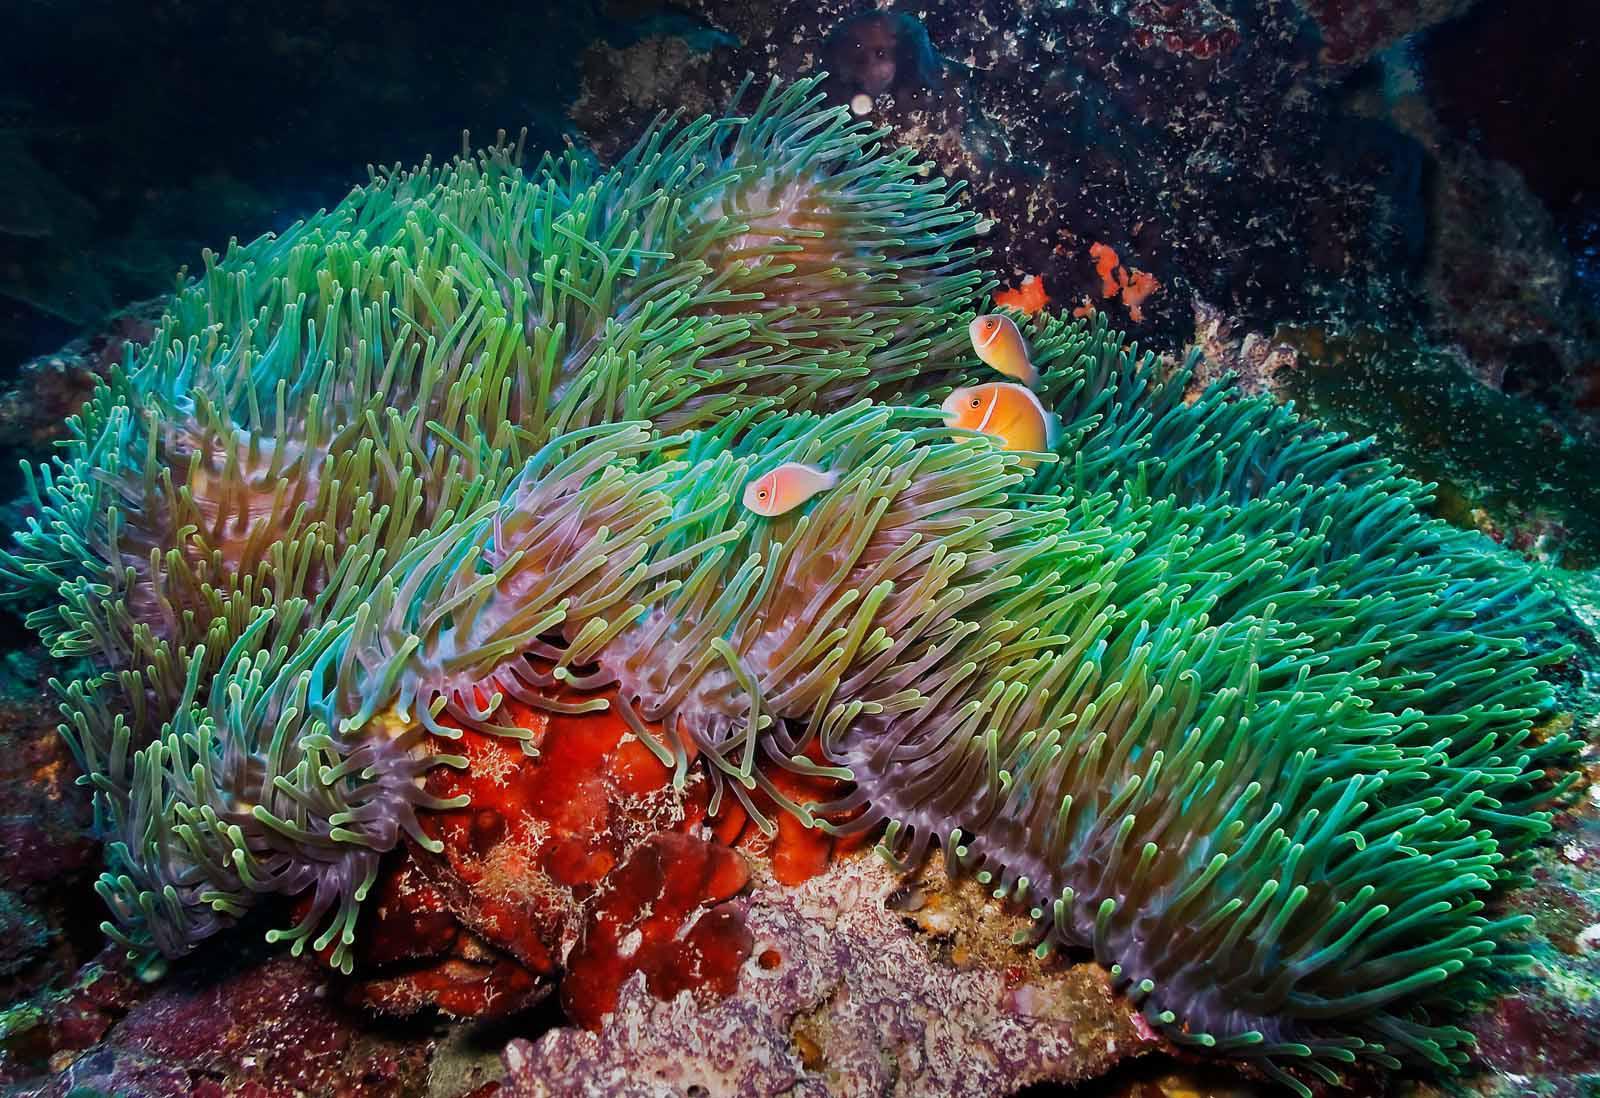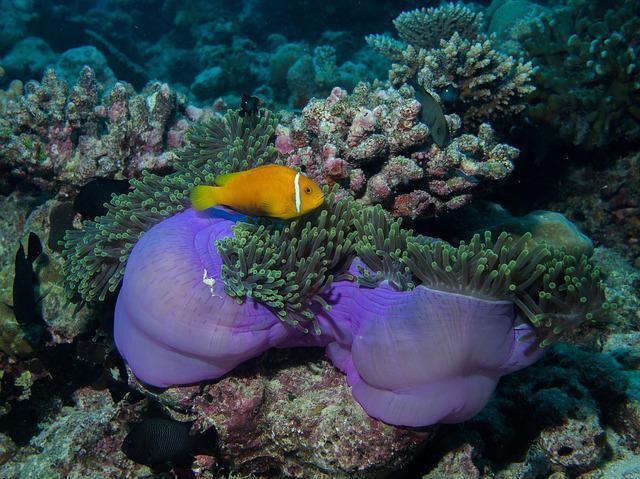The first image is the image on the left, the second image is the image on the right. Given the left and right images, does the statement "In at least one image, there is a single purple round corral underneath green corral arms that fish are swimming through." hold true? Answer yes or no. No. The first image is the image on the left, the second image is the image on the right. Examine the images to the left and right. Is the description "The right image shows at least two orange fish swimming in tendrils that sprout from an anemone's round purple stalk." accurate? Answer yes or no. No. 